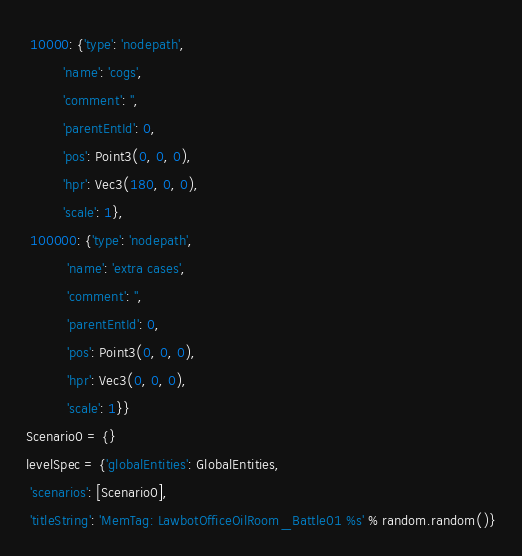<code> <loc_0><loc_0><loc_500><loc_500><_Python_> 10000: {'type': 'nodepath',
         'name': 'cogs',
         'comment': '',
         'parentEntId': 0,
         'pos': Point3(0, 0, 0),
         'hpr': Vec3(180, 0, 0),
         'scale': 1},
 100000: {'type': 'nodepath',
          'name': 'extra cases',
          'comment': '',
          'parentEntId': 0,
          'pos': Point3(0, 0, 0),
          'hpr': Vec3(0, 0, 0),
          'scale': 1}}
Scenario0 = {}
levelSpec = {'globalEntities': GlobalEntities,
 'scenarios': [Scenario0],
 'titleString': 'MemTag: LawbotOfficeOilRoom_Battle01 %s' % random.random()}
</code> 